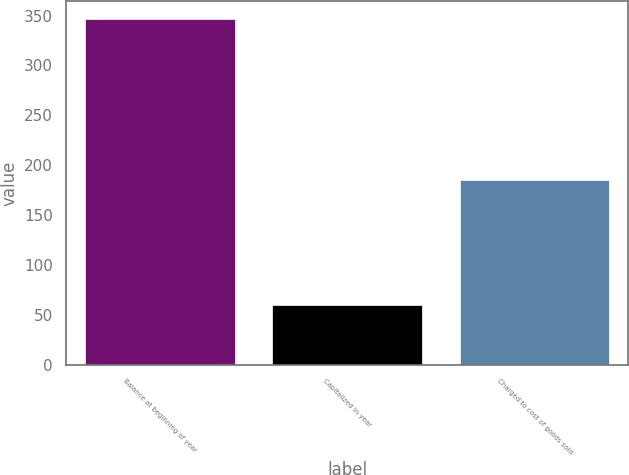Convert chart to OTSL. <chart><loc_0><loc_0><loc_500><loc_500><bar_chart><fcel>Balance at beginning of year<fcel>Capitalized in year<fcel>Charged to cost of goods sold<nl><fcel>347<fcel>60<fcel>185<nl></chart> 